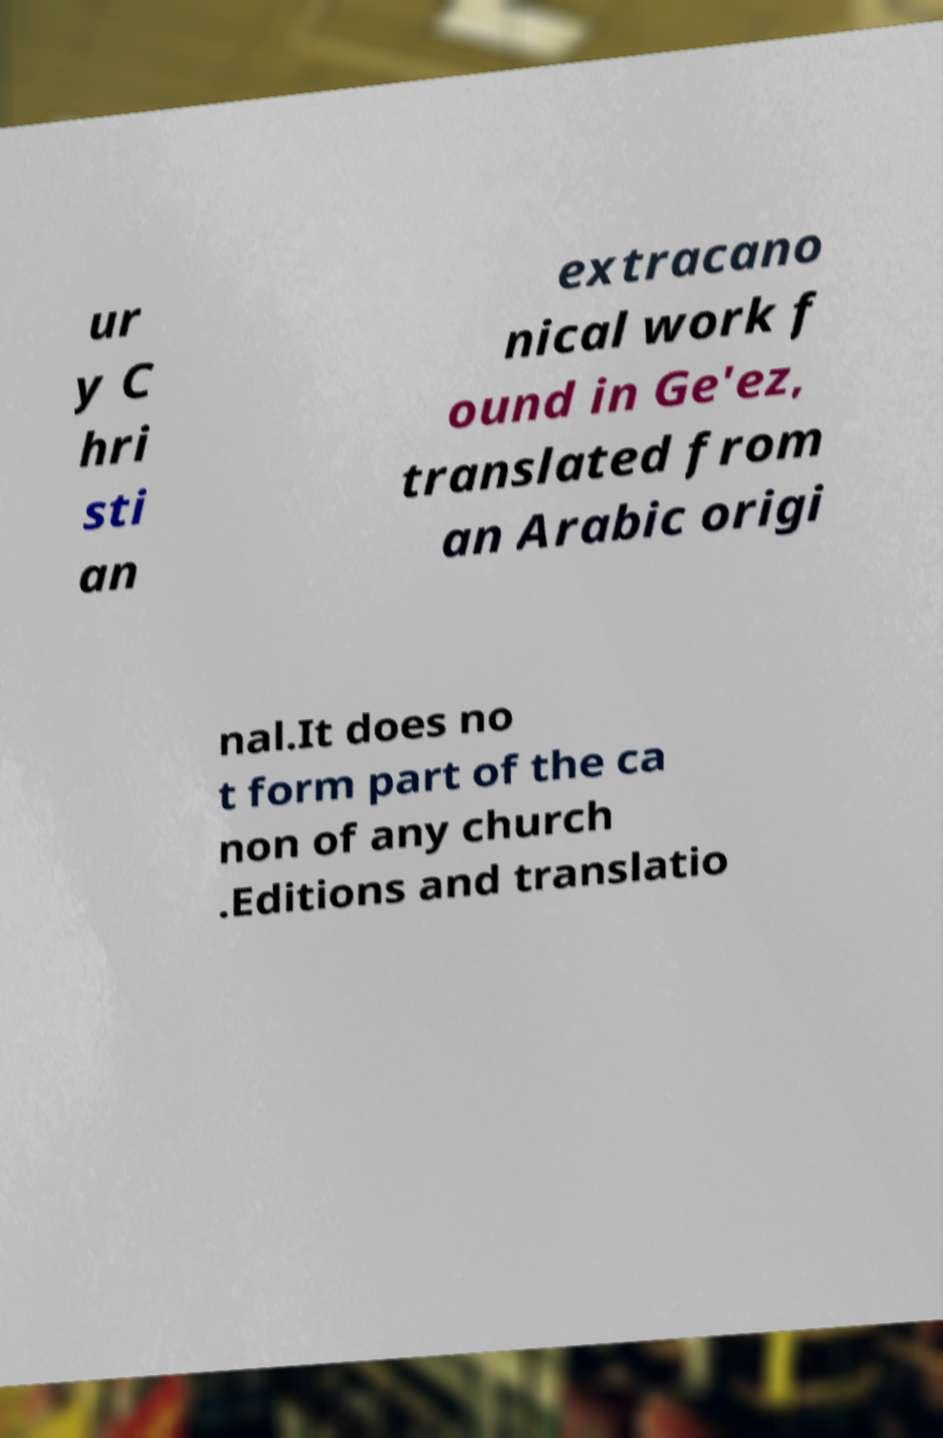Could you extract and type out the text from this image? ur y C hri sti an extracano nical work f ound in Ge'ez, translated from an Arabic origi nal.It does no t form part of the ca non of any church .Editions and translatio 